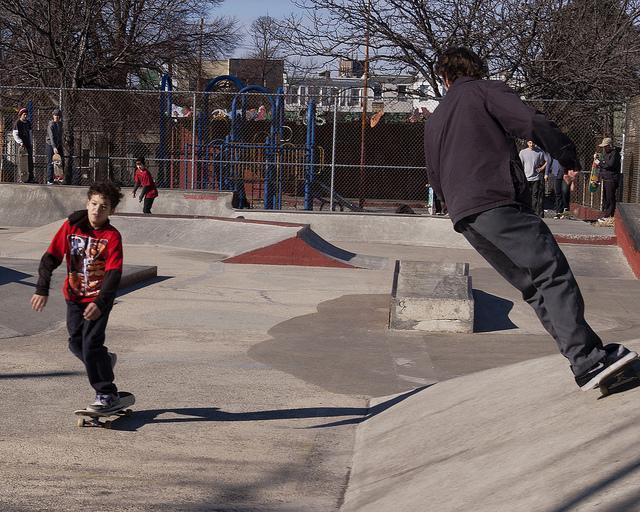How many people are shown?
Give a very brief answer. 8. How many children are wearing red coats?
Give a very brief answer. 2. How many people are in the picture?
Give a very brief answer. 2. 